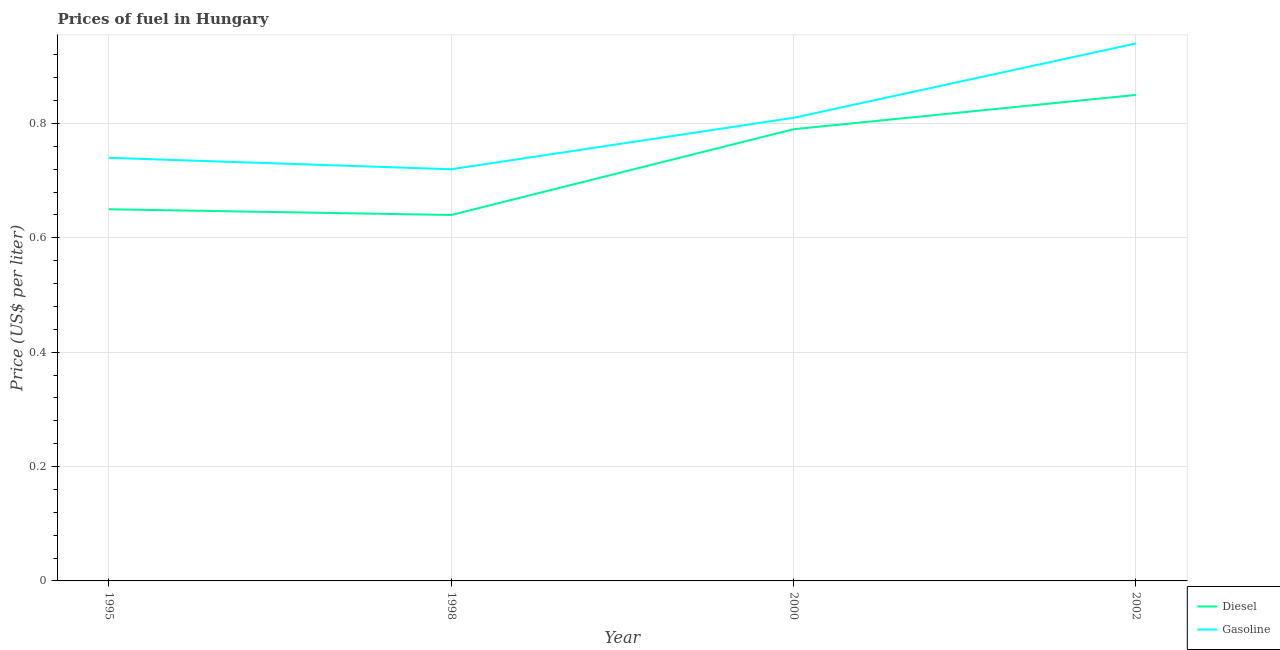How many different coloured lines are there?
Keep it short and to the point. 2. What is the diesel price in 1998?
Provide a short and direct response. 0.64. Across all years, what is the minimum diesel price?
Make the answer very short. 0.64. In which year was the gasoline price maximum?
Provide a succinct answer. 2002. In which year was the gasoline price minimum?
Your answer should be compact. 1998. What is the total gasoline price in the graph?
Give a very brief answer. 3.21. What is the difference between the gasoline price in 2000 and that in 2002?
Give a very brief answer. -0.13. What is the difference between the diesel price in 2000 and the gasoline price in 1995?
Provide a short and direct response. 0.05. What is the average gasoline price per year?
Provide a short and direct response. 0.8. In the year 1998, what is the difference between the gasoline price and diesel price?
Make the answer very short. 0.08. In how many years, is the gasoline price greater than 0.56 US$ per litre?
Give a very brief answer. 4. What is the ratio of the gasoline price in 1998 to that in 2000?
Make the answer very short. 0.89. Is the diesel price in 1995 less than that in 2000?
Provide a succinct answer. Yes. Is the difference between the diesel price in 1995 and 2002 greater than the difference between the gasoline price in 1995 and 2002?
Keep it short and to the point. No. What is the difference between the highest and the second highest gasoline price?
Your answer should be compact. 0.13. What is the difference between the highest and the lowest gasoline price?
Ensure brevity in your answer.  0.22. In how many years, is the gasoline price greater than the average gasoline price taken over all years?
Provide a succinct answer. 2. Is the sum of the diesel price in 1998 and 2002 greater than the maximum gasoline price across all years?
Offer a very short reply. Yes. Does the gasoline price monotonically increase over the years?
Your response must be concise. No. Is the diesel price strictly greater than the gasoline price over the years?
Keep it short and to the point. No. Is the gasoline price strictly less than the diesel price over the years?
Offer a terse response. No. How many years are there in the graph?
Keep it short and to the point. 4. Are the values on the major ticks of Y-axis written in scientific E-notation?
Make the answer very short. No. Does the graph contain any zero values?
Your response must be concise. No. Does the graph contain grids?
Your answer should be very brief. Yes. Where does the legend appear in the graph?
Keep it short and to the point. Bottom right. What is the title of the graph?
Your answer should be very brief. Prices of fuel in Hungary. What is the label or title of the X-axis?
Make the answer very short. Year. What is the label or title of the Y-axis?
Keep it short and to the point. Price (US$ per liter). What is the Price (US$ per liter) of Diesel in 1995?
Offer a very short reply. 0.65. What is the Price (US$ per liter) of Gasoline in 1995?
Give a very brief answer. 0.74. What is the Price (US$ per liter) of Diesel in 1998?
Your answer should be very brief. 0.64. What is the Price (US$ per liter) in Gasoline in 1998?
Make the answer very short. 0.72. What is the Price (US$ per liter) in Diesel in 2000?
Provide a succinct answer. 0.79. What is the Price (US$ per liter) of Gasoline in 2000?
Offer a terse response. 0.81. What is the Price (US$ per liter) in Gasoline in 2002?
Ensure brevity in your answer.  0.94. Across all years, what is the maximum Price (US$ per liter) in Diesel?
Your response must be concise. 0.85. Across all years, what is the minimum Price (US$ per liter) of Diesel?
Your response must be concise. 0.64. Across all years, what is the minimum Price (US$ per liter) in Gasoline?
Keep it short and to the point. 0.72. What is the total Price (US$ per liter) in Diesel in the graph?
Offer a terse response. 2.93. What is the total Price (US$ per liter) of Gasoline in the graph?
Offer a terse response. 3.21. What is the difference between the Price (US$ per liter) in Gasoline in 1995 and that in 1998?
Your answer should be compact. 0.02. What is the difference between the Price (US$ per liter) in Diesel in 1995 and that in 2000?
Offer a very short reply. -0.14. What is the difference between the Price (US$ per liter) of Gasoline in 1995 and that in 2000?
Your answer should be very brief. -0.07. What is the difference between the Price (US$ per liter) of Gasoline in 1995 and that in 2002?
Offer a terse response. -0.2. What is the difference between the Price (US$ per liter) of Gasoline in 1998 and that in 2000?
Your answer should be very brief. -0.09. What is the difference between the Price (US$ per liter) of Diesel in 1998 and that in 2002?
Keep it short and to the point. -0.21. What is the difference between the Price (US$ per liter) in Gasoline in 1998 and that in 2002?
Give a very brief answer. -0.22. What is the difference between the Price (US$ per liter) of Diesel in 2000 and that in 2002?
Keep it short and to the point. -0.06. What is the difference between the Price (US$ per liter) in Gasoline in 2000 and that in 2002?
Give a very brief answer. -0.13. What is the difference between the Price (US$ per liter) of Diesel in 1995 and the Price (US$ per liter) of Gasoline in 1998?
Your answer should be very brief. -0.07. What is the difference between the Price (US$ per liter) in Diesel in 1995 and the Price (US$ per liter) in Gasoline in 2000?
Make the answer very short. -0.16. What is the difference between the Price (US$ per liter) of Diesel in 1995 and the Price (US$ per liter) of Gasoline in 2002?
Provide a succinct answer. -0.29. What is the difference between the Price (US$ per liter) of Diesel in 1998 and the Price (US$ per liter) of Gasoline in 2000?
Provide a short and direct response. -0.17. What is the average Price (US$ per liter) in Diesel per year?
Your answer should be compact. 0.73. What is the average Price (US$ per liter) in Gasoline per year?
Make the answer very short. 0.8. In the year 1995, what is the difference between the Price (US$ per liter) of Diesel and Price (US$ per liter) of Gasoline?
Provide a short and direct response. -0.09. In the year 1998, what is the difference between the Price (US$ per liter) in Diesel and Price (US$ per liter) in Gasoline?
Keep it short and to the point. -0.08. In the year 2000, what is the difference between the Price (US$ per liter) in Diesel and Price (US$ per liter) in Gasoline?
Your response must be concise. -0.02. In the year 2002, what is the difference between the Price (US$ per liter) of Diesel and Price (US$ per liter) of Gasoline?
Your answer should be very brief. -0.09. What is the ratio of the Price (US$ per liter) in Diesel in 1995 to that in 1998?
Offer a terse response. 1.02. What is the ratio of the Price (US$ per liter) of Gasoline in 1995 to that in 1998?
Provide a succinct answer. 1.03. What is the ratio of the Price (US$ per liter) of Diesel in 1995 to that in 2000?
Your answer should be compact. 0.82. What is the ratio of the Price (US$ per liter) of Gasoline in 1995 to that in 2000?
Keep it short and to the point. 0.91. What is the ratio of the Price (US$ per liter) in Diesel in 1995 to that in 2002?
Make the answer very short. 0.76. What is the ratio of the Price (US$ per liter) in Gasoline in 1995 to that in 2002?
Offer a very short reply. 0.79. What is the ratio of the Price (US$ per liter) of Diesel in 1998 to that in 2000?
Your answer should be compact. 0.81. What is the ratio of the Price (US$ per liter) of Gasoline in 1998 to that in 2000?
Provide a succinct answer. 0.89. What is the ratio of the Price (US$ per liter) in Diesel in 1998 to that in 2002?
Offer a very short reply. 0.75. What is the ratio of the Price (US$ per liter) of Gasoline in 1998 to that in 2002?
Offer a very short reply. 0.77. What is the ratio of the Price (US$ per liter) of Diesel in 2000 to that in 2002?
Keep it short and to the point. 0.93. What is the ratio of the Price (US$ per liter) of Gasoline in 2000 to that in 2002?
Your answer should be very brief. 0.86. What is the difference between the highest and the second highest Price (US$ per liter) of Gasoline?
Give a very brief answer. 0.13. What is the difference between the highest and the lowest Price (US$ per liter) in Diesel?
Offer a very short reply. 0.21. What is the difference between the highest and the lowest Price (US$ per liter) of Gasoline?
Your response must be concise. 0.22. 